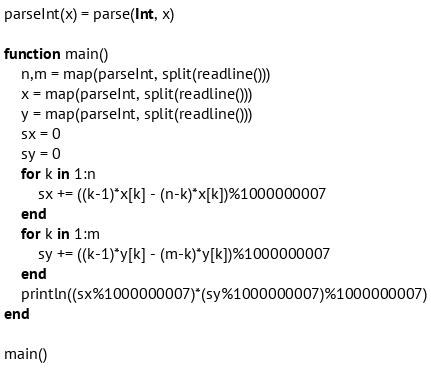Convert code to text. <code><loc_0><loc_0><loc_500><loc_500><_Julia_>parseInt(x) = parse(Int, x)

function main()
	n,m = map(parseInt, split(readline()))
	x = map(parseInt, split(readline()))
	y = map(parseInt, split(readline()))
	sx = 0
	sy = 0
	for k in 1:n
		sx += ((k-1)*x[k] - (n-k)*x[k])%1000000007
	end
    for k in 1:m
		sy += ((k-1)*y[k] - (m-k)*y[k])%1000000007
    end
	println((sx%1000000007)*(sy%1000000007)%1000000007)
end

main()</code> 